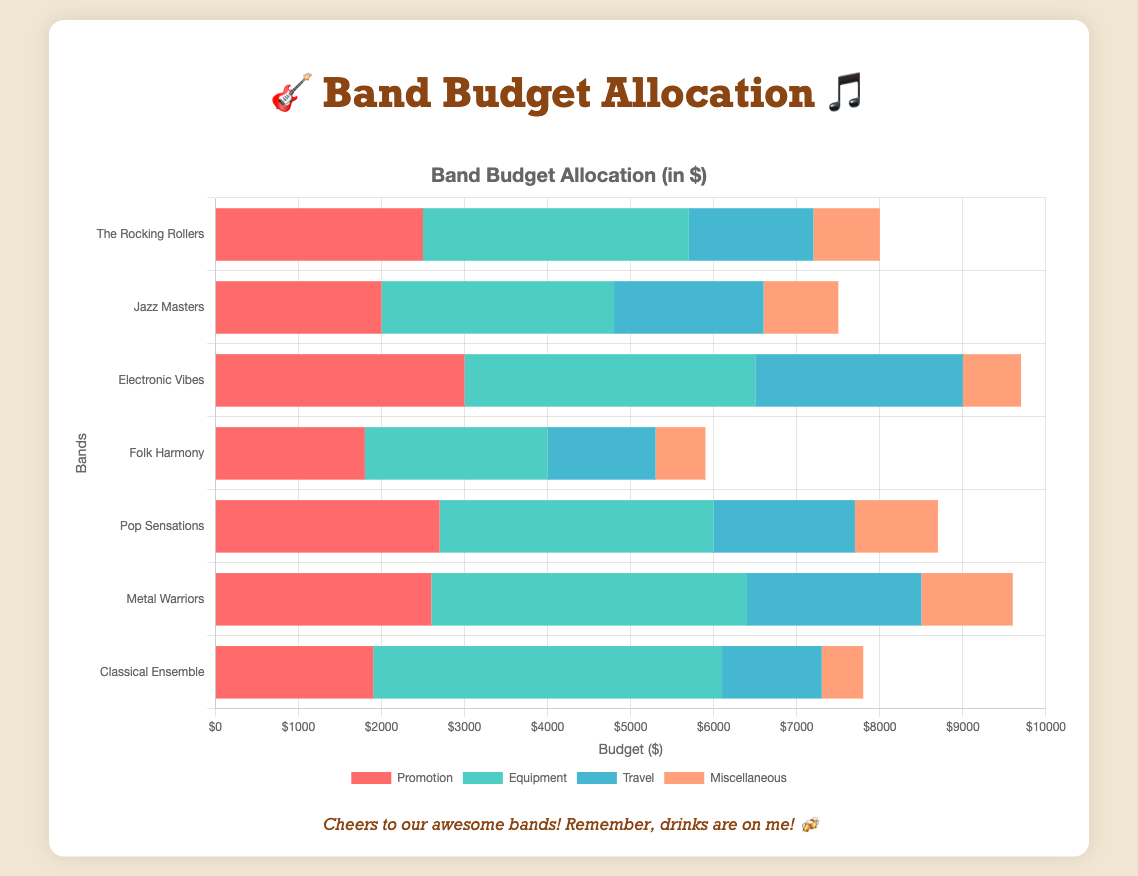Who spends the most on travel? The band that spends the most on travel is identified by comparing the travel expenses for each band.
Answer: Electronic Vibes Which band allocates the least amount to equipment? Compare the equipment expenses across all bands and find the smallest value. Folk Harmony spends the least on equipment.
Answer: Folk Harmony What's the total budget for Pop Sensations? Add up the values for all categories for Pop Sensations: 2700 (promotion) + 3300 (equipment) + 1700 (travel) + 1000 (miscellaneous).
Answer: 8700 Which band has the highest budget allocation for miscellaneous expenses? Check the miscellaneous expenses for each band. Metal Warriors allocates the most to miscellaneous expenses.
Answer: Metal Warriors Compare the promotion budget of The Rocking Rollers and Classical Ensemble. Which one is higher? Compare the promotion budgets: The Rocking Rollers have 2500, and Classical Ensemble has 1900.
Answer: The Rocking Rollers What's the combined budget allocation for equipment for The Rocking Rollers and Jazz Masters? Sum the equipment budgets: The Rocking Rollers (3200) + Jazz Masters (2800).
Answer: 6000 Which category does Folk Harmony spend the most on? Look at the budget breakdown for Folk Harmony to find the largest value: promotion (1800), equipment (2200), travel (1300), miscellaneous (600).
Answer: Equipment What's the difference in travel budget between Electronic Vibes and Jazz Masters? Calculate the difference: Electronic Vibes (2500) - Jazz Masters (1800).
Answer: 700 If you combine the promotion budgets of The Rocking Rollers and Pop Sensations, how much would that be? Add the promotion budgets of both bands: The Rocking Rollers (2500) + Pop Sensations (2700).
Answer: 5200 Which band has the smallest overall budget allocation? Calculate the total budget for each band and compare. Folk Harmony has the smallest total: 1800 (promotion) + 2200 (equipment) + 1300 (travel) + 600 (miscellaneous).
Answer: Folk Harmony Considering only Pop Sensations and Metal Warriors, which band spends more on travel, and by how much? Compare the travel expenses: Pop Sensations (1700) and Metal Warriors (2100). Metal Warriors spends more. Calculate the difference: 2100 - 1700.
Answer: Metal Warriors, 400 